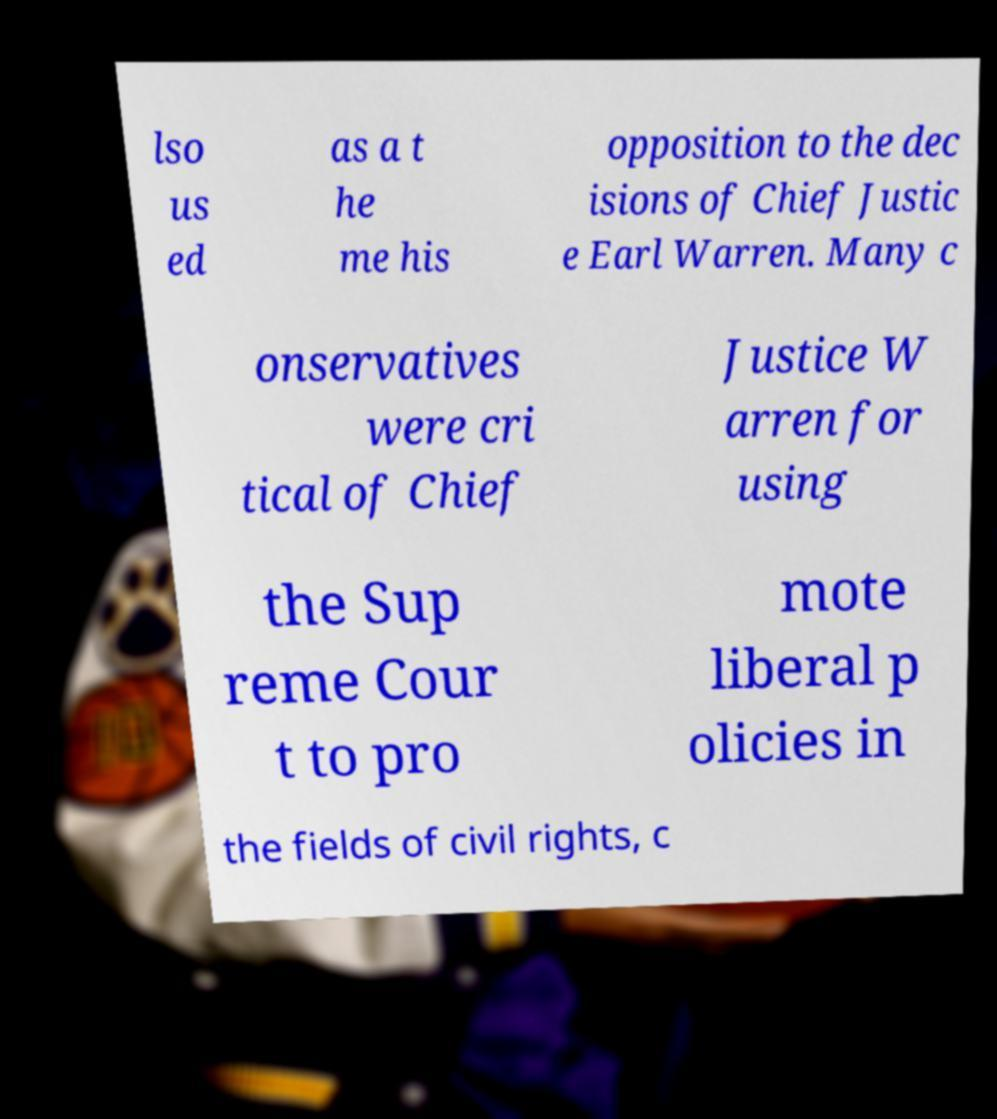I need the written content from this picture converted into text. Can you do that? lso us ed as a t he me his opposition to the dec isions of Chief Justic e Earl Warren. Many c onservatives were cri tical of Chief Justice W arren for using the Sup reme Cour t to pro mote liberal p olicies in the fields of civil rights, c 